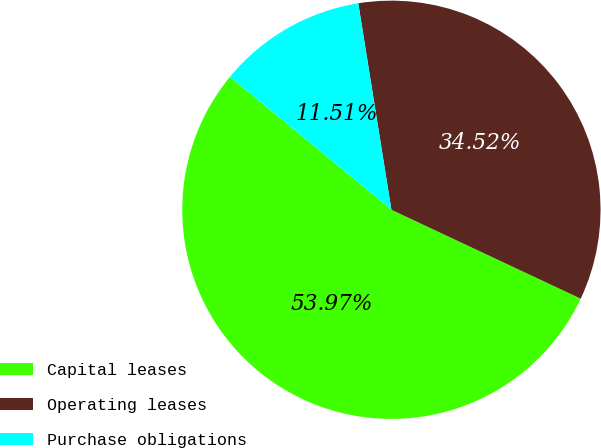<chart> <loc_0><loc_0><loc_500><loc_500><pie_chart><fcel>Capital leases<fcel>Operating leases<fcel>Purchase obligations<nl><fcel>53.97%<fcel>34.52%<fcel>11.51%<nl></chart> 